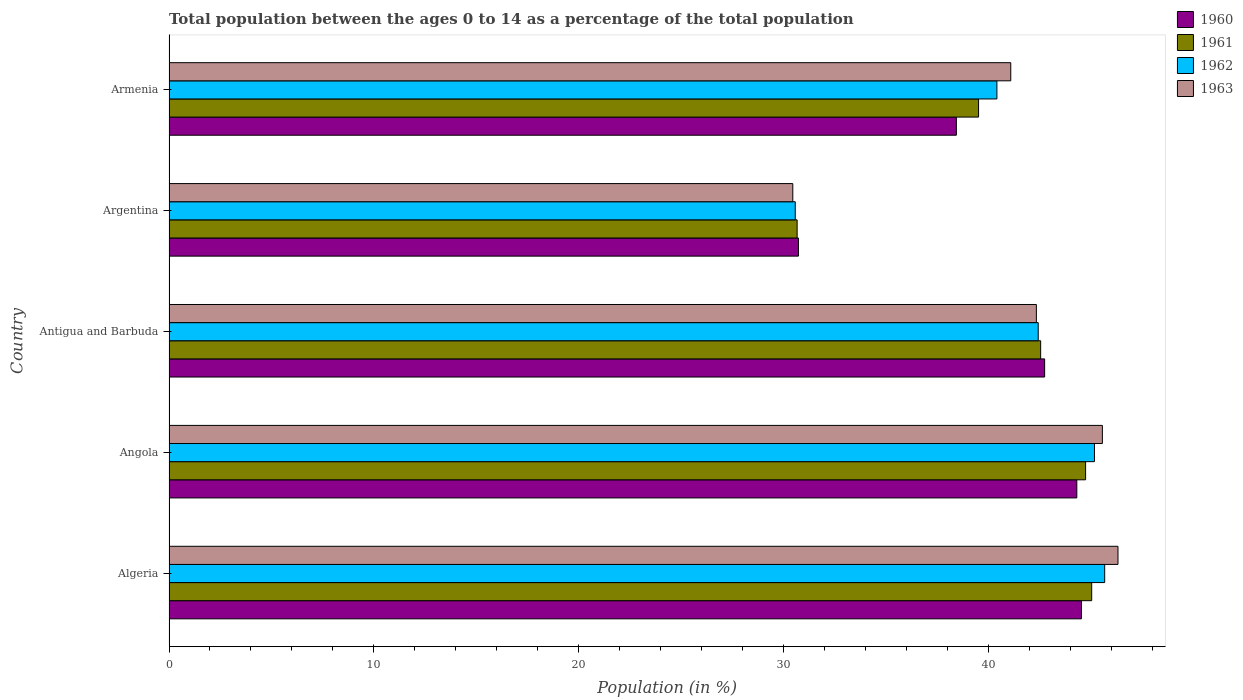Are the number of bars on each tick of the Y-axis equal?
Ensure brevity in your answer.  Yes. How many bars are there on the 2nd tick from the top?
Offer a very short reply. 4. What is the label of the 3rd group of bars from the top?
Ensure brevity in your answer.  Antigua and Barbuda. In how many cases, is the number of bars for a given country not equal to the number of legend labels?
Offer a very short reply. 0. What is the percentage of the population ages 0 to 14 in 1963 in Algeria?
Your answer should be very brief. 46.32. Across all countries, what is the maximum percentage of the population ages 0 to 14 in 1963?
Keep it short and to the point. 46.32. Across all countries, what is the minimum percentage of the population ages 0 to 14 in 1961?
Your answer should be compact. 30.66. In which country was the percentage of the population ages 0 to 14 in 1960 maximum?
Keep it short and to the point. Algeria. What is the total percentage of the population ages 0 to 14 in 1962 in the graph?
Your answer should be compact. 204.26. What is the difference between the percentage of the population ages 0 to 14 in 1963 in Antigua and Barbuda and that in Armenia?
Your answer should be compact. 1.25. What is the difference between the percentage of the population ages 0 to 14 in 1962 in Antigua and Barbuda and the percentage of the population ages 0 to 14 in 1960 in Angola?
Your response must be concise. -1.88. What is the average percentage of the population ages 0 to 14 in 1962 per country?
Make the answer very short. 40.85. What is the difference between the percentage of the population ages 0 to 14 in 1961 and percentage of the population ages 0 to 14 in 1962 in Argentina?
Offer a very short reply. 0.09. In how many countries, is the percentage of the population ages 0 to 14 in 1963 greater than 36 ?
Your answer should be compact. 4. What is the ratio of the percentage of the population ages 0 to 14 in 1962 in Algeria to that in Angola?
Your answer should be compact. 1.01. Is the percentage of the population ages 0 to 14 in 1960 in Argentina less than that in Armenia?
Your answer should be compact. Yes. What is the difference between the highest and the second highest percentage of the population ages 0 to 14 in 1960?
Offer a terse response. 0.23. What is the difference between the highest and the lowest percentage of the population ages 0 to 14 in 1961?
Provide a succinct answer. 14.38. Is it the case that in every country, the sum of the percentage of the population ages 0 to 14 in 1960 and percentage of the population ages 0 to 14 in 1962 is greater than the sum of percentage of the population ages 0 to 14 in 1963 and percentage of the population ages 0 to 14 in 1961?
Provide a succinct answer. No. What does the 2nd bar from the top in Antigua and Barbuda represents?
Ensure brevity in your answer.  1962. Is it the case that in every country, the sum of the percentage of the population ages 0 to 14 in 1961 and percentage of the population ages 0 to 14 in 1963 is greater than the percentage of the population ages 0 to 14 in 1960?
Give a very brief answer. Yes. How many countries are there in the graph?
Keep it short and to the point. 5. What is the difference between two consecutive major ticks on the X-axis?
Offer a terse response. 10. Are the values on the major ticks of X-axis written in scientific E-notation?
Your answer should be very brief. No. Does the graph contain grids?
Your answer should be very brief. No. Where does the legend appear in the graph?
Make the answer very short. Top right. How many legend labels are there?
Provide a succinct answer. 4. What is the title of the graph?
Give a very brief answer. Total population between the ages 0 to 14 as a percentage of the total population. What is the label or title of the Y-axis?
Keep it short and to the point. Country. What is the Population (in %) of 1960 in Algeria?
Your response must be concise. 44.54. What is the Population (in %) in 1961 in Algeria?
Give a very brief answer. 45.04. What is the Population (in %) of 1962 in Algeria?
Offer a very short reply. 45.67. What is the Population (in %) in 1963 in Algeria?
Provide a succinct answer. 46.32. What is the Population (in %) in 1960 in Angola?
Offer a terse response. 44.31. What is the Population (in %) in 1961 in Angola?
Your response must be concise. 44.74. What is the Population (in %) of 1962 in Angola?
Make the answer very short. 45.17. What is the Population (in %) in 1963 in Angola?
Your answer should be very brief. 45.56. What is the Population (in %) in 1960 in Antigua and Barbuda?
Your answer should be compact. 42.74. What is the Population (in %) of 1961 in Antigua and Barbuda?
Ensure brevity in your answer.  42.55. What is the Population (in %) of 1962 in Antigua and Barbuda?
Keep it short and to the point. 42.43. What is the Population (in %) of 1963 in Antigua and Barbuda?
Provide a succinct answer. 42.34. What is the Population (in %) of 1960 in Argentina?
Your answer should be compact. 30.73. What is the Population (in %) of 1961 in Argentina?
Make the answer very short. 30.66. What is the Population (in %) in 1962 in Argentina?
Ensure brevity in your answer.  30.57. What is the Population (in %) of 1963 in Argentina?
Provide a succinct answer. 30.45. What is the Population (in %) of 1960 in Armenia?
Your answer should be compact. 38.43. What is the Population (in %) of 1961 in Armenia?
Provide a succinct answer. 39.52. What is the Population (in %) of 1962 in Armenia?
Your response must be concise. 40.41. What is the Population (in %) of 1963 in Armenia?
Your response must be concise. 41.09. Across all countries, what is the maximum Population (in %) in 1960?
Keep it short and to the point. 44.54. Across all countries, what is the maximum Population (in %) of 1961?
Your response must be concise. 45.04. Across all countries, what is the maximum Population (in %) of 1962?
Your response must be concise. 45.67. Across all countries, what is the maximum Population (in %) of 1963?
Make the answer very short. 46.32. Across all countries, what is the minimum Population (in %) of 1960?
Offer a very short reply. 30.73. Across all countries, what is the minimum Population (in %) in 1961?
Provide a short and direct response. 30.66. Across all countries, what is the minimum Population (in %) of 1962?
Your response must be concise. 30.57. Across all countries, what is the minimum Population (in %) in 1963?
Ensure brevity in your answer.  30.45. What is the total Population (in %) of 1960 in the graph?
Your response must be concise. 200.75. What is the total Population (in %) of 1961 in the graph?
Ensure brevity in your answer.  202.51. What is the total Population (in %) in 1962 in the graph?
Offer a very short reply. 204.26. What is the total Population (in %) of 1963 in the graph?
Your answer should be very brief. 205.76. What is the difference between the Population (in %) of 1960 in Algeria and that in Angola?
Ensure brevity in your answer.  0.23. What is the difference between the Population (in %) of 1961 in Algeria and that in Angola?
Give a very brief answer. 0.3. What is the difference between the Population (in %) in 1962 in Algeria and that in Angola?
Your response must be concise. 0.5. What is the difference between the Population (in %) in 1963 in Algeria and that in Angola?
Your response must be concise. 0.76. What is the difference between the Population (in %) in 1960 in Algeria and that in Antigua and Barbuda?
Your answer should be compact. 1.8. What is the difference between the Population (in %) in 1961 in Algeria and that in Antigua and Barbuda?
Offer a terse response. 2.49. What is the difference between the Population (in %) of 1962 in Algeria and that in Antigua and Barbuda?
Offer a very short reply. 3.25. What is the difference between the Population (in %) in 1963 in Algeria and that in Antigua and Barbuda?
Your answer should be compact. 3.98. What is the difference between the Population (in %) of 1960 in Algeria and that in Argentina?
Give a very brief answer. 13.81. What is the difference between the Population (in %) of 1961 in Algeria and that in Argentina?
Offer a very short reply. 14.38. What is the difference between the Population (in %) in 1962 in Algeria and that in Argentina?
Make the answer very short. 15.1. What is the difference between the Population (in %) in 1963 in Algeria and that in Argentina?
Your response must be concise. 15.87. What is the difference between the Population (in %) in 1960 in Algeria and that in Armenia?
Provide a short and direct response. 6.11. What is the difference between the Population (in %) in 1961 in Algeria and that in Armenia?
Your answer should be very brief. 5.52. What is the difference between the Population (in %) in 1962 in Algeria and that in Armenia?
Your answer should be compact. 5.26. What is the difference between the Population (in %) in 1963 in Algeria and that in Armenia?
Keep it short and to the point. 5.23. What is the difference between the Population (in %) of 1960 in Angola and that in Antigua and Barbuda?
Your answer should be very brief. 1.57. What is the difference between the Population (in %) in 1961 in Angola and that in Antigua and Barbuda?
Your answer should be very brief. 2.19. What is the difference between the Population (in %) of 1962 in Angola and that in Antigua and Barbuda?
Offer a very short reply. 2.75. What is the difference between the Population (in %) in 1963 in Angola and that in Antigua and Barbuda?
Offer a very short reply. 3.22. What is the difference between the Population (in %) of 1960 in Angola and that in Argentina?
Provide a succinct answer. 13.59. What is the difference between the Population (in %) in 1961 in Angola and that in Argentina?
Your answer should be compact. 14.08. What is the difference between the Population (in %) in 1962 in Angola and that in Argentina?
Offer a very short reply. 14.61. What is the difference between the Population (in %) in 1963 in Angola and that in Argentina?
Offer a terse response. 15.11. What is the difference between the Population (in %) of 1960 in Angola and that in Armenia?
Ensure brevity in your answer.  5.88. What is the difference between the Population (in %) of 1961 in Angola and that in Armenia?
Your answer should be compact. 5.22. What is the difference between the Population (in %) of 1962 in Angola and that in Armenia?
Your answer should be very brief. 4.76. What is the difference between the Population (in %) in 1963 in Angola and that in Armenia?
Your response must be concise. 4.47. What is the difference between the Population (in %) of 1960 in Antigua and Barbuda and that in Argentina?
Your response must be concise. 12.02. What is the difference between the Population (in %) of 1961 in Antigua and Barbuda and that in Argentina?
Give a very brief answer. 11.89. What is the difference between the Population (in %) of 1962 in Antigua and Barbuda and that in Argentina?
Your answer should be compact. 11.86. What is the difference between the Population (in %) of 1963 in Antigua and Barbuda and that in Argentina?
Provide a succinct answer. 11.89. What is the difference between the Population (in %) in 1960 in Antigua and Barbuda and that in Armenia?
Your answer should be very brief. 4.31. What is the difference between the Population (in %) in 1961 in Antigua and Barbuda and that in Armenia?
Make the answer very short. 3.03. What is the difference between the Population (in %) in 1962 in Antigua and Barbuda and that in Armenia?
Your answer should be compact. 2.02. What is the difference between the Population (in %) of 1963 in Antigua and Barbuda and that in Armenia?
Ensure brevity in your answer.  1.25. What is the difference between the Population (in %) in 1960 in Argentina and that in Armenia?
Offer a terse response. -7.71. What is the difference between the Population (in %) in 1961 in Argentina and that in Armenia?
Offer a terse response. -8.86. What is the difference between the Population (in %) in 1962 in Argentina and that in Armenia?
Make the answer very short. -9.84. What is the difference between the Population (in %) in 1963 in Argentina and that in Armenia?
Provide a short and direct response. -10.64. What is the difference between the Population (in %) in 1960 in Algeria and the Population (in %) in 1961 in Angola?
Ensure brevity in your answer.  -0.2. What is the difference between the Population (in %) of 1960 in Algeria and the Population (in %) of 1962 in Angola?
Your response must be concise. -0.64. What is the difference between the Population (in %) of 1960 in Algeria and the Population (in %) of 1963 in Angola?
Make the answer very short. -1.02. What is the difference between the Population (in %) in 1961 in Algeria and the Population (in %) in 1962 in Angola?
Provide a succinct answer. -0.14. What is the difference between the Population (in %) of 1961 in Algeria and the Population (in %) of 1963 in Angola?
Your response must be concise. -0.52. What is the difference between the Population (in %) in 1962 in Algeria and the Population (in %) in 1963 in Angola?
Provide a succinct answer. 0.11. What is the difference between the Population (in %) in 1960 in Algeria and the Population (in %) in 1961 in Antigua and Barbuda?
Ensure brevity in your answer.  1.99. What is the difference between the Population (in %) in 1960 in Algeria and the Population (in %) in 1962 in Antigua and Barbuda?
Offer a very short reply. 2.11. What is the difference between the Population (in %) in 1960 in Algeria and the Population (in %) in 1963 in Antigua and Barbuda?
Make the answer very short. 2.2. What is the difference between the Population (in %) of 1961 in Algeria and the Population (in %) of 1962 in Antigua and Barbuda?
Offer a very short reply. 2.61. What is the difference between the Population (in %) of 1961 in Algeria and the Population (in %) of 1963 in Antigua and Barbuda?
Your answer should be compact. 2.7. What is the difference between the Population (in %) in 1962 in Algeria and the Population (in %) in 1963 in Antigua and Barbuda?
Your answer should be compact. 3.33. What is the difference between the Population (in %) of 1960 in Algeria and the Population (in %) of 1961 in Argentina?
Your response must be concise. 13.88. What is the difference between the Population (in %) of 1960 in Algeria and the Population (in %) of 1962 in Argentina?
Your response must be concise. 13.97. What is the difference between the Population (in %) in 1960 in Algeria and the Population (in %) in 1963 in Argentina?
Your answer should be compact. 14.09. What is the difference between the Population (in %) of 1961 in Algeria and the Population (in %) of 1962 in Argentina?
Ensure brevity in your answer.  14.47. What is the difference between the Population (in %) in 1961 in Algeria and the Population (in %) in 1963 in Argentina?
Make the answer very short. 14.59. What is the difference between the Population (in %) of 1962 in Algeria and the Population (in %) of 1963 in Argentina?
Give a very brief answer. 15.22. What is the difference between the Population (in %) of 1960 in Algeria and the Population (in %) of 1961 in Armenia?
Your answer should be compact. 5.02. What is the difference between the Population (in %) of 1960 in Algeria and the Population (in %) of 1962 in Armenia?
Keep it short and to the point. 4.13. What is the difference between the Population (in %) of 1960 in Algeria and the Population (in %) of 1963 in Armenia?
Your response must be concise. 3.45. What is the difference between the Population (in %) of 1961 in Algeria and the Population (in %) of 1962 in Armenia?
Offer a very short reply. 4.63. What is the difference between the Population (in %) of 1961 in Algeria and the Population (in %) of 1963 in Armenia?
Your answer should be compact. 3.95. What is the difference between the Population (in %) in 1962 in Algeria and the Population (in %) in 1963 in Armenia?
Offer a terse response. 4.58. What is the difference between the Population (in %) of 1960 in Angola and the Population (in %) of 1961 in Antigua and Barbuda?
Keep it short and to the point. 1.76. What is the difference between the Population (in %) of 1960 in Angola and the Population (in %) of 1962 in Antigua and Barbuda?
Make the answer very short. 1.88. What is the difference between the Population (in %) of 1960 in Angola and the Population (in %) of 1963 in Antigua and Barbuda?
Give a very brief answer. 1.97. What is the difference between the Population (in %) in 1961 in Angola and the Population (in %) in 1962 in Antigua and Barbuda?
Give a very brief answer. 2.31. What is the difference between the Population (in %) in 1961 in Angola and the Population (in %) in 1963 in Antigua and Barbuda?
Offer a terse response. 2.4. What is the difference between the Population (in %) in 1962 in Angola and the Population (in %) in 1963 in Antigua and Barbuda?
Your response must be concise. 2.84. What is the difference between the Population (in %) of 1960 in Angola and the Population (in %) of 1961 in Argentina?
Ensure brevity in your answer.  13.65. What is the difference between the Population (in %) of 1960 in Angola and the Population (in %) of 1962 in Argentina?
Your answer should be very brief. 13.74. What is the difference between the Population (in %) in 1960 in Angola and the Population (in %) in 1963 in Argentina?
Your response must be concise. 13.86. What is the difference between the Population (in %) of 1961 in Angola and the Population (in %) of 1962 in Argentina?
Provide a succinct answer. 14.17. What is the difference between the Population (in %) in 1961 in Angola and the Population (in %) in 1963 in Argentina?
Your answer should be very brief. 14.29. What is the difference between the Population (in %) of 1962 in Angola and the Population (in %) of 1963 in Argentina?
Provide a succinct answer. 14.73. What is the difference between the Population (in %) in 1960 in Angola and the Population (in %) in 1961 in Armenia?
Your answer should be compact. 4.8. What is the difference between the Population (in %) in 1960 in Angola and the Population (in %) in 1962 in Armenia?
Make the answer very short. 3.9. What is the difference between the Population (in %) of 1960 in Angola and the Population (in %) of 1963 in Armenia?
Provide a short and direct response. 3.22. What is the difference between the Population (in %) of 1961 in Angola and the Population (in %) of 1962 in Armenia?
Keep it short and to the point. 4.33. What is the difference between the Population (in %) of 1961 in Angola and the Population (in %) of 1963 in Armenia?
Give a very brief answer. 3.65. What is the difference between the Population (in %) in 1962 in Angola and the Population (in %) in 1963 in Armenia?
Provide a succinct answer. 4.09. What is the difference between the Population (in %) in 1960 in Antigua and Barbuda and the Population (in %) in 1961 in Argentina?
Offer a terse response. 12.08. What is the difference between the Population (in %) in 1960 in Antigua and Barbuda and the Population (in %) in 1962 in Argentina?
Your answer should be compact. 12.17. What is the difference between the Population (in %) of 1960 in Antigua and Barbuda and the Population (in %) of 1963 in Argentina?
Offer a terse response. 12.29. What is the difference between the Population (in %) in 1961 in Antigua and Barbuda and the Population (in %) in 1962 in Argentina?
Provide a succinct answer. 11.98. What is the difference between the Population (in %) in 1961 in Antigua and Barbuda and the Population (in %) in 1963 in Argentina?
Offer a very short reply. 12.1. What is the difference between the Population (in %) of 1962 in Antigua and Barbuda and the Population (in %) of 1963 in Argentina?
Offer a very short reply. 11.98. What is the difference between the Population (in %) of 1960 in Antigua and Barbuda and the Population (in %) of 1961 in Armenia?
Provide a short and direct response. 3.23. What is the difference between the Population (in %) in 1960 in Antigua and Barbuda and the Population (in %) in 1962 in Armenia?
Provide a short and direct response. 2.33. What is the difference between the Population (in %) of 1960 in Antigua and Barbuda and the Population (in %) of 1963 in Armenia?
Make the answer very short. 1.65. What is the difference between the Population (in %) of 1961 in Antigua and Barbuda and the Population (in %) of 1962 in Armenia?
Give a very brief answer. 2.14. What is the difference between the Population (in %) of 1961 in Antigua and Barbuda and the Population (in %) of 1963 in Armenia?
Your answer should be compact. 1.46. What is the difference between the Population (in %) in 1962 in Antigua and Barbuda and the Population (in %) in 1963 in Armenia?
Provide a succinct answer. 1.34. What is the difference between the Population (in %) in 1960 in Argentina and the Population (in %) in 1961 in Armenia?
Keep it short and to the point. -8.79. What is the difference between the Population (in %) in 1960 in Argentina and the Population (in %) in 1962 in Armenia?
Ensure brevity in your answer.  -9.69. What is the difference between the Population (in %) of 1960 in Argentina and the Population (in %) of 1963 in Armenia?
Your answer should be very brief. -10.36. What is the difference between the Population (in %) in 1961 in Argentina and the Population (in %) in 1962 in Armenia?
Ensure brevity in your answer.  -9.75. What is the difference between the Population (in %) of 1961 in Argentina and the Population (in %) of 1963 in Armenia?
Give a very brief answer. -10.43. What is the difference between the Population (in %) in 1962 in Argentina and the Population (in %) in 1963 in Armenia?
Provide a succinct answer. -10.52. What is the average Population (in %) in 1960 per country?
Ensure brevity in your answer.  40.15. What is the average Population (in %) of 1961 per country?
Provide a short and direct response. 40.5. What is the average Population (in %) of 1962 per country?
Provide a succinct answer. 40.85. What is the average Population (in %) in 1963 per country?
Your answer should be very brief. 41.15. What is the difference between the Population (in %) of 1960 and Population (in %) of 1961 in Algeria?
Your response must be concise. -0.5. What is the difference between the Population (in %) in 1960 and Population (in %) in 1962 in Algeria?
Your response must be concise. -1.13. What is the difference between the Population (in %) of 1960 and Population (in %) of 1963 in Algeria?
Provide a short and direct response. -1.78. What is the difference between the Population (in %) of 1961 and Population (in %) of 1962 in Algeria?
Make the answer very short. -0.64. What is the difference between the Population (in %) in 1961 and Population (in %) in 1963 in Algeria?
Provide a succinct answer. -1.28. What is the difference between the Population (in %) of 1962 and Population (in %) of 1963 in Algeria?
Offer a terse response. -0.65. What is the difference between the Population (in %) of 1960 and Population (in %) of 1961 in Angola?
Keep it short and to the point. -0.43. What is the difference between the Population (in %) in 1960 and Population (in %) in 1962 in Angola?
Provide a succinct answer. -0.86. What is the difference between the Population (in %) in 1960 and Population (in %) in 1963 in Angola?
Ensure brevity in your answer.  -1.25. What is the difference between the Population (in %) in 1961 and Population (in %) in 1962 in Angola?
Provide a short and direct response. -0.43. What is the difference between the Population (in %) in 1961 and Population (in %) in 1963 in Angola?
Provide a short and direct response. -0.82. What is the difference between the Population (in %) in 1962 and Population (in %) in 1963 in Angola?
Provide a succinct answer. -0.39. What is the difference between the Population (in %) of 1960 and Population (in %) of 1961 in Antigua and Barbuda?
Offer a very short reply. 0.19. What is the difference between the Population (in %) in 1960 and Population (in %) in 1962 in Antigua and Barbuda?
Provide a succinct answer. 0.31. What is the difference between the Population (in %) of 1960 and Population (in %) of 1963 in Antigua and Barbuda?
Your response must be concise. 0.4. What is the difference between the Population (in %) in 1961 and Population (in %) in 1962 in Antigua and Barbuda?
Provide a succinct answer. 0.12. What is the difference between the Population (in %) in 1961 and Population (in %) in 1963 in Antigua and Barbuda?
Your response must be concise. 0.21. What is the difference between the Population (in %) of 1962 and Population (in %) of 1963 in Antigua and Barbuda?
Ensure brevity in your answer.  0.09. What is the difference between the Population (in %) of 1960 and Population (in %) of 1961 in Argentina?
Keep it short and to the point. 0.07. What is the difference between the Population (in %) in 1960 and Population (in %) in 1962 in Argentina?
Give a very brief answer. 0.16. What is the difference between the Population (in %) in 1960 and Population (in %) in 1963 in Argentina?
Make the answer very short. 0.28. What is the difference between the Population (in %) in 1961 and Population (in %) in 1962 in Argentina?
Make the answer very short. 0.09. What is the difference between the Population (in %) in 1961 and Population (in %) in 1963 in Argentina?
Provide a succinct answer. 0.21. What is the difference between the Population (in %) of 1962 and Population (in %) of 1963 in Argentina?
Your answer should be compact. 0.12. What is the difference between the Population (in %) in 1960 and Population (in %) in 1961 in Armenia?
Offer a terse response. -1.08. What is the difference between the Population (in %) in 1960 and Population (in %) in 1962 in Armenia?
Your answer should be compact. -1.98. What is the difference between the Population (in %) in 1960 and Population (in %) in 1963 in Armenia?
Provide a short and direct response. -2.66. What is the difference between the Population (in %) of 1961 and Population (in %) of 1962 in Armenia?
Your answer should be compact. -0.89. What is the difference between the Population (in %) in 1961 and Population (in %) in 1963 in Armenia?
Offer a terse response. -1.57. What is the difference between the Population (in %) of 1962 and Population (in %) of 1963 in Armenia?
Give a very brief answer. -0.68. What is the ratio of the Population (in %) of 1960 in Algeria to that in Angola?
Your answer should be very brief. 1.01. What is the ratio of the Population (in %) in 1961 in Algeria to that in Angola?
Your answer should be very brief. 1.01. What is the ratio of the Population (in %) in 1963 in Algeria to that in Angola?
Your answer should be compact. 1.02. What is the ratio of the Population (in %) of 1960 in Algeria to that in Antigua and Barbuda?
Make the answer very short. 1.04. What is the ratio of the Population (in %) in 1961 in Algeria to that in Antigua and Barbuda?
Your answer should be very brief. 1.06. What is the ratio of the Population (in %) in 1962 in Algeria to that in Antigua and Barbuda?
Make the answer very short. 1.08. What is the ratio of the Population (in %) of 1963 in Algeria to that in Antigua and Barbuda?
Your answer should be compact. 1.09. What is the ratio of the Population (in %) in 1960 in Algeria to that in Argentina?
Your answer should be very brief. 1.45. What is the ratio of the Population (in %) of 1961 in Algeria to that in Argentina?
Your response must be concise. 1.47. What is the ratio of the Population (in %) of 1962 in Algeria to that in Argentina?
Offer a very short reply. 1.49. What is the ratio of the Population (in %) of 1963 in Algeria to that in Argentina?
Offer a very short reply. 1.52. What is the ratio of the Population (in %) in 1960 in Algeria to that in Armenia?
Provide a succinct answer. 1.16. What is the ratio of the Population (in %) of 1961 in Algeria to that in Armenia?
Your answer should be compact. 1.14. What is the ratio of the Population (in %) in 1962 in Algeria to that in Armenia?
Make the answer very short. 1.13. What is the ratio of the Population (in %) of 1963 in Algeria to that in Armenia?
Make the answer very short. 1.13. What is the ratio of the Population (in %) in 1960 in Angola to that in Antigua and Barbuda?
Your answer should be compact. 1.04. What is the ratio of the Population (in %) of 1961 in Angola to that in Antigua and Barbuda?
Your response must be concise. 1.05. What is the ratio of the Population (in %) of 1962 in Angola to that in Antigua and Barbuda?
Keep it short and to the point. 1.06. What is the ratio of the Population (in %) of 1963 in Angola to that in Antigua and Barbuda?
Provide a short and direct response. 1.08. What is the ratio of the Population (in %) in 1960 in Angola to that in Argentina?
Your answer should be compact. 1.44. What is the ratio of the Population (in %) of 1961 in Angola to that in Argentina?
Provide a succinct answer. 1.46. What is the ratio of the Population (in %) in 1962 in Angola to that in Argentina?
Make the answer very short. 1.48. What is the ratio of the Population (in %) of 1963 in Angola to that in Argentina?
Your answer should be compact. 1.5. What is the ratio of the Population (in %) in 1960 in Angola to that in Armenia?
Give a very brief answer. 1.15. What is the ratio of the Population (in %) in 1961 in Angola to that in Armenia?
Provide a succinct answer. 1.13. What is the ratio of the Population (in %) of 1962 in Angola to that in Armenia?
Provide a short and direct response. 1.12. What is the ratio of the Population (in %) of 1963 in Angola to that in Armenia?
Provide a short and direct response. 1.11. What is the ratio of the Population (in %) in 1960 in Antigua and Barbuda to that in Argentina?
Keep it short and to the point. 1.39. What is the ratio of the Population (in %) of 1961 in Antigua and Barbuda to that in Argentina?
Make the answer very short. 1.39. What is the ratio of the Population (in %) in 1962 in Antigua and Barbuda to that in Argentina?
Give a very brief answer. 1.39. What is the ratio of the Population (in %) in 1963 in Antigua and Barbuda to that in Argentina?
Give a very brief answer. 1.39. What is the ratio of the Population (in %) of 1960 in Antigua and Barbuda to that in Armenia?
Your answer should be very brief. 1.11. What is the ratio of the Population (in %) of 1961 in Antigua and Barbuda to that in Armenia?
Provide a succinct answer. 1.08. What is the ratio of the Population (in %) of 1962 in Antigua and Barbuda to that in Armenia?
Make the answer very short. 1.05. What is the ratio of the Population (in %) of 1963 in Antigua and Barbuda to that in Armenia?
Your response must be concise. 1.03. What is the ratio of the Population (in %) of 1960 in Argentina to that in Armenia?
Your answer should be very brief. 0.8. What is the ratio of the Population (in %) of 1961 in Argentina to that in Armenia?
Ensure brevity in your answer.  0.78. What is the ratio of the Population (in %) in 1962 in Argentina to that in Armenia?
Provide a succinct answer. 0.76. What is the ratio of the Population (in %) of 1963 in Argentina to that in Armenia?
Provide a short and direct response. 0.74. What is the difference between the highest and the second highest Population (in %) of 1960?
Provide a short and direct response. 0.23. What is the difference between the highest and the second highest Population (in %) in 1961?
Provide a short and direct response. 0.3. What is the difference between the highest and the second highest Population (in %) in 1962?
Keep it short and to the point. 0.5. What is the difference between the highest and the second highest Population (in %) in 1963?
Keep it short and to the point. 0.76. What is the difference between the highest and the lowest Population (in %) of 1960?
Give a very brief answer. 13.81. What is the difference between the highest and the lowest Population (in %) of 1961?
Provide a succinct answer. 14.38. What is the difference between the highest and the lowest Population (in %) in 1962?
Your answer should be very brief. 15.1. What is the difference between the highest and the lowest Population (in %) in 1963?
Your answer should be compact. 15.87. 